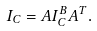Convert formula to latex. <formula><loc_0><loc_0><loc_500><loc_500>I _ { C } = A I _ { C } ^ { B } A ^ { T } .</formula> 